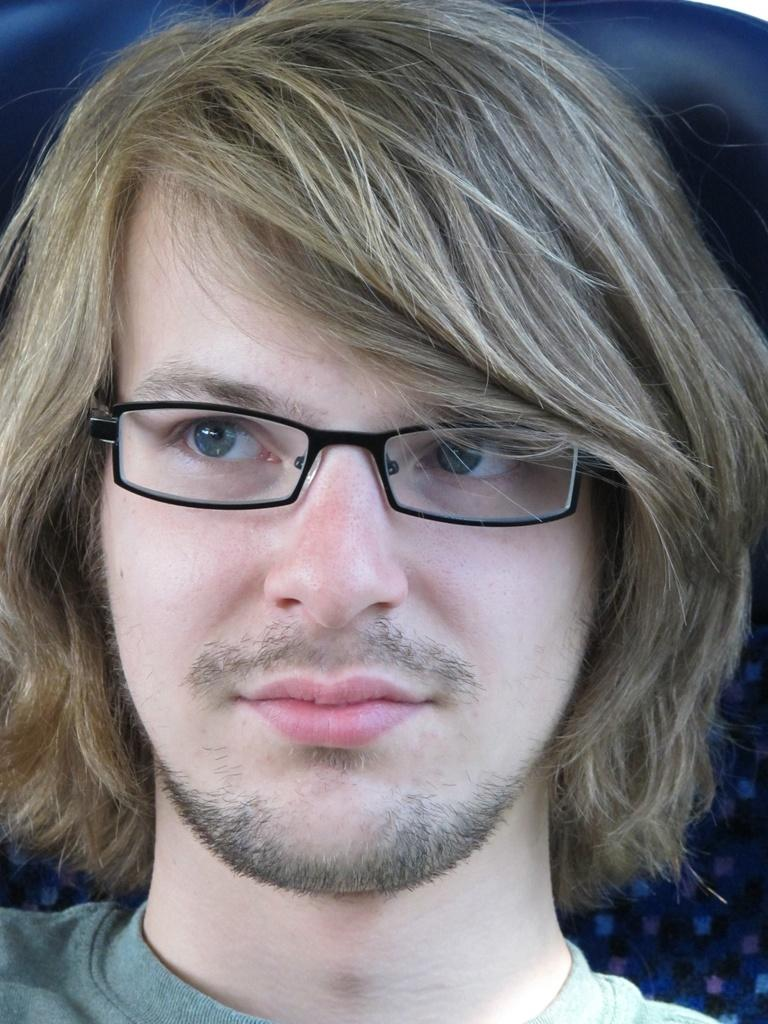Who is present in the image? There is a man in the image. What is the man wearing on his face? The man is wearing spectacles. What type of soup is the ladybug eating during the meeting in the image? There is no ladybug or soup present in the image, and therefore no such activity can be observed. 